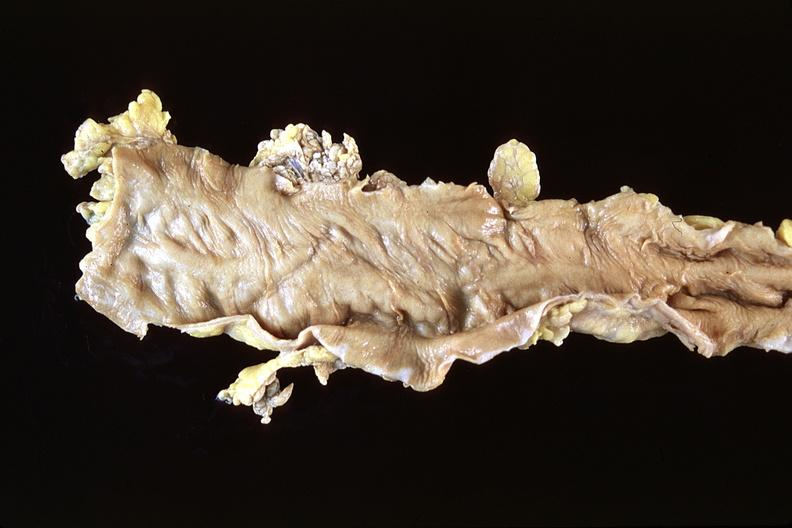where does this belong to?
Answer the question using a single word or phrase. Gastrointestinal system 